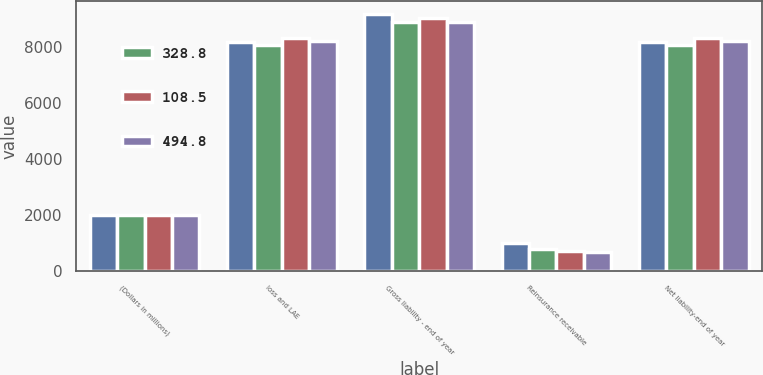<chart> <loc_0><loc_0><loc_500><loc_500><stacked_bar_chart><ecel><fcel>(Dollars in millions)<fcel>loss and LAE<fcel>Gross liability - end of year<fcel>Reinsurance receivable<fcel>Net liability-end of year<nl><fcel>nan<fcel>2005<fcel>8175.4<fcel>9175.1<fcel>999.7<fcel>8175.4<nl><fcel>328.8<fcel>2006<fcel>8078.9<fcel>8888<fcel>809.1<fcel>8078.9<nl><fcel>108.5<fcel>2007<fcel>8324.7<fcel>9032.2<fcel>707.4<fcel>8324.7<nl><fcel>494.8<fcel>2008<fcel>8214.7<fcel>8905.9<fcel>691.2<fcel>8214.7<nl></chart> 